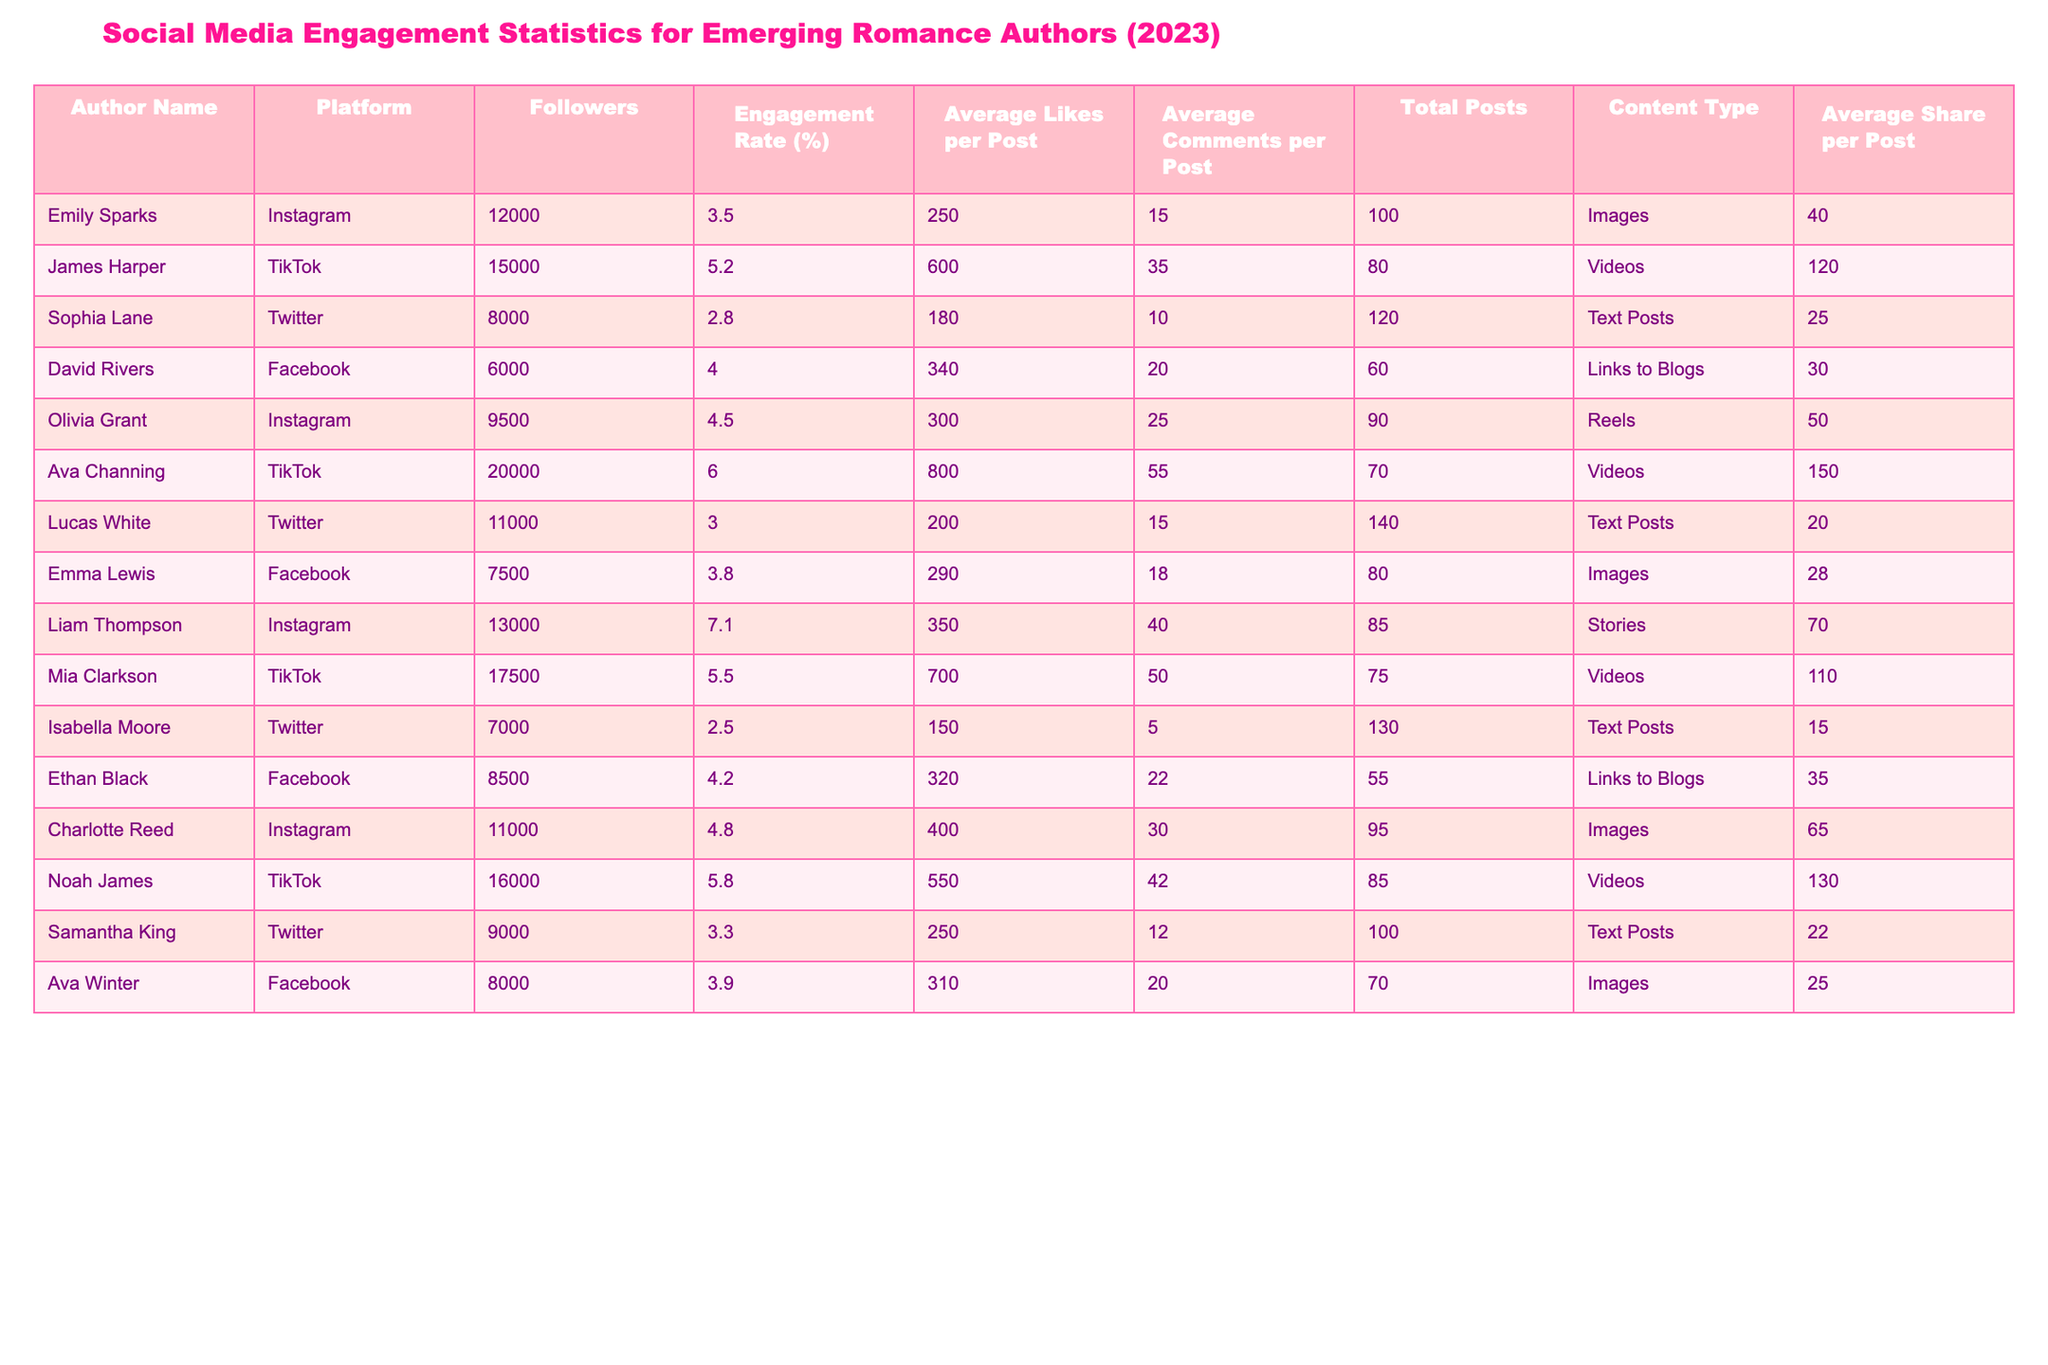What is the engagement rate of Olivia Grant on Instagram? Looking at the row for Olivia Grant, the engagement rate listed in the table is 4.5%.
Answer: 4.5% Which author has the highest number of followers on TikTok? By comparing the follower counts of the authors on TikTok, Ava Channing has the highest number of followers at 20,000.
Answer: 20,000 Calculate the average engagement rate of all authors listed. To find the average, sum up all engagement rates: (3.5 + 5.2 + 2.8 + 4.0 + 4.5 + 6.0 + 3.0 + 3.8 + 7.1 + 5.5 + 2.5 + 4.2 + 3.9) = 58.0. There are 13 authors, so the average is 58.0 / 13 ≈ 4.46.
Answer: 4.46 Which author received the highest average likes per post? Upon reviewing the table, Ava Channing on TikTok received the highest average likes per post at 800.
Answer: 800 Is Charlotte Reed's engagement rate higher than Liam Thompson’s? Charlotte Reed has an engagement rate of 4.8%, while Liam Thompson has an engagement rate of 7.1%. Since 4.8% < 7.1%, the answer is no.
Answer: No Which platform shows the lowest average comments per post among all authors? To determine this, we observe the average comments per post across the platforms: Instagram (varied), TikTok (varied), Twitter (varied), Facebook (ranging between 18 and 30). The lowest is found with Isabella Moore on Twitter, where the average is 5.
Answer: 5 How many total posts did David Rivers make on Facebook? The table indicates that David Rivers made a total of 60 posts on Facebook.
Answer: 60 What is the sum of average shares per post for all authors on Instagram? The average shares per post for authors on Instagram are: Emily Sparks (40) + Olivia Grant (50) + Liam Thompson (70) + Charlotte Reed (65). Adding these together gives 40 + 50 + 70 + 65 = 225.
Answer: 225 Which author on Twitter has the highest engagement rate? Among the authors on Twitter, Noah James has the highest engagement rate at 5.8%.
Answer: 5.8% Does Mia Clarkson have more followers on TikTok than Ethan Black has on Facebook? Mia Clarkson has 17,500 followers on TikTok while Ethan Black has 8,500 on Facebook. Since 17,500 > 8,500, the answer is yes.
Answer: Yes What are the average comments per post for authors using the 'Videos' content type? The average comments for authors using videos are as follows: James Harper (35), Ava Channing (55), Mia Clarkson (50), Noah James (42). The total is 35 + 55 + 50 + 42 = 182 with 4 authors, so the average is 182 / 4 = 45.5.
Answer: 45.5 